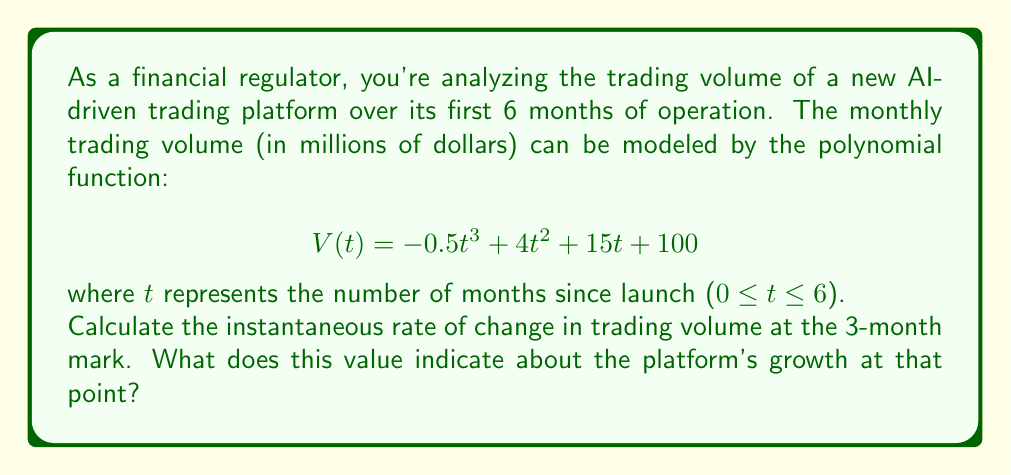What is the answer to this math problem? To solve this problem, we need to follow these steps:

1) The instantaneous rate of change at any point is given by the derivative of the function at that point.

2) Let's find the derivative of $V(t)$:
   $$V'(t) = \frac{d}{dt}(-0.5t^3 + 4t^2 + 15t + 100)$$
   $$V'(t) = -1.5t^2 + 8t + 15$$

3) We want to find the rate of change at t = 3 months, so we'll substitute t = 3 into $V'(t)$:
   $$V'(3) = -1.5(3)^2 + 8(3) + 15$$
   $$V'(3) = -1.5(9) + 24 + 15$$
   $$V'(3) = -13.5 + 24 + 15$$
   $$V'(3) = 25.5$$

4) Interpret the result:
   The instantaneous rate of change at t = 3 is 25.5 million dollars per month.
   This positive value indicates that the trading volume is increasing at the 3-month mark.
   Specifically, it's growing at a rate of $25.5 million per month at that instant.

This information is crucial for a financial regulator to assess the platform's growth trajectory and ensure it aligns with regulatory expectations and market stability concerns.
Answer: The instantaneous rate of change in trading volume at the 3-month mark is $25.5$ million dollars per month, indicating the platform is experiencing significant growth at that point. 